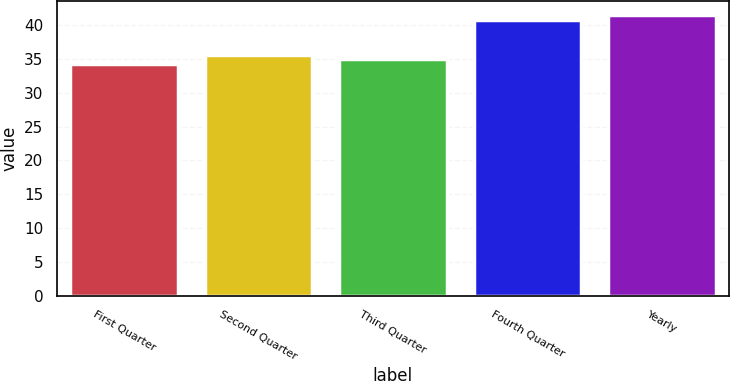Convert chart. <chart><loc_0><loc_0><loc_500><loc_500><bar_chart><fcel>First Quarter<fcel>Second Quarter<fcel>Third Quarter<fcel>Fourth Quarter<fcel>Yearly<nl><fcel>34.28<fcel>35.61<fcel>34.95<fcel>40.84<fcel>41.5<nl></chart> 